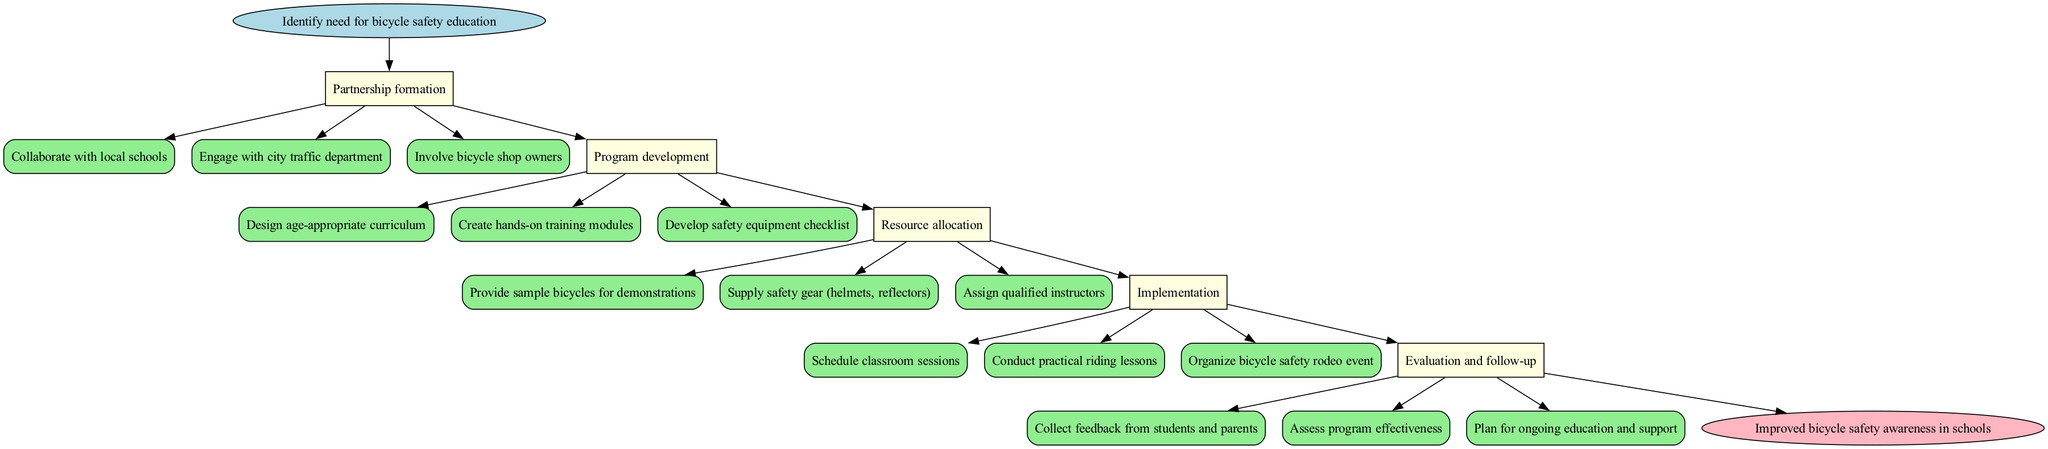What is the starting point of the clinical pathway? The starting point of the clinical pathway is the "Identify need for bicycle safety education." This can be seen at the very top of the diagram before the first step.
Answer: Identify need for bicycle safety education How many main steps are there in the pathway? There are five main steps in the pathway: Partnership formation, Program development, Resource allocation, Implementation, and Evaluation and follow-up. This information can be counted from the distinct labeled boxes under the start node.
Answer: 5 What activity is associated with the Resource allocation step? One of the activities associated with the Resource allocation step is "Provide sample bicycles for demonstrations." This is listed as one of the specific tasks under that step in the diagram.
Answer: Provide sample bicycles for demonstrations What follows the Implementation step in the pathway? The Evaluation and follow-up step follows the Implementation step, as indicated by the edge that connects the two steps in the diagram.
Answer: Evaluation and follow-up What color represents the activities in the diagram? The activities in the diagram are represented in light green color, as shown by the color coding for the rectangles representing activities.
Answer: Light green Which step includes "Collect feedback from students and parents"? "Collect feedback from students and parents" is included in the Evaluation and follow-up step, where the program's effectiveness is assessed. This can be identified as one of the activities listed under that specific step.
Answer: Evaluation and follow-up Which activity is directly connected to the Program development step? The activity "Design age-appropriate curriculum" is directly connected to the Program development step, as it is one of the key activities listed under that step in the diagram.
Answer: Design age-appropriate curriculum What is the final outcome of the clinical pathway? The final outcome of the clinical pathway is "Improved bicycle safety awareness in schools," which is indicated at the bottom of the diagram as the endpoint.
Answer: Improved bicycle safety awareness in schools Which two steps are directly linked together before the end? The Implementation step and the Evaluation and follow-up step are directly linked together before leading to the end node. This connection can be identified through their sequential arrangement in the diagram.
Answer: Implementation and Evaluation and follow-up 